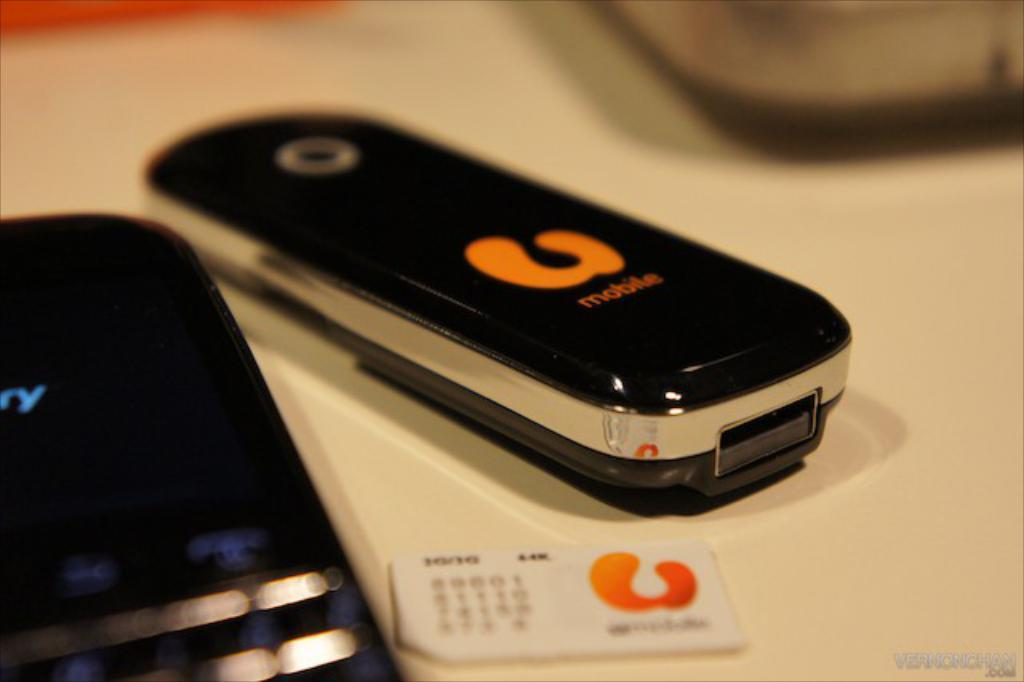<image>
Create a compact narrative representing the image presented. a U mobile phone is sitting on a table 